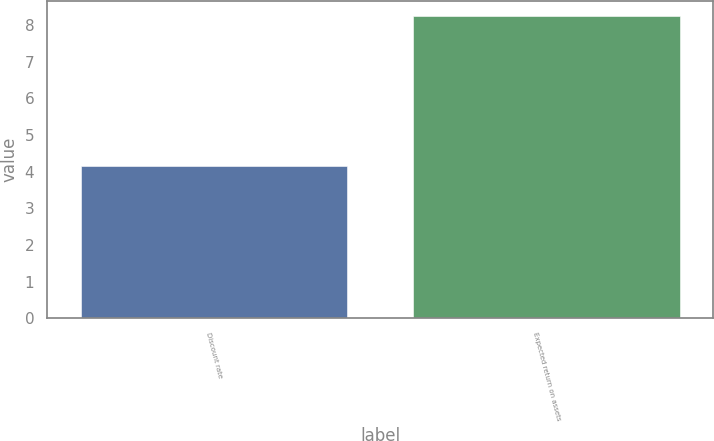Convert chart to OTSL. <chart><loc_0><loc_0><loc_500><loc_500><bar_chart><fcel>Discount rate<fcel>Expected return on assets<nl><fcel>4.15<fcel>8.25<nl></chart> 